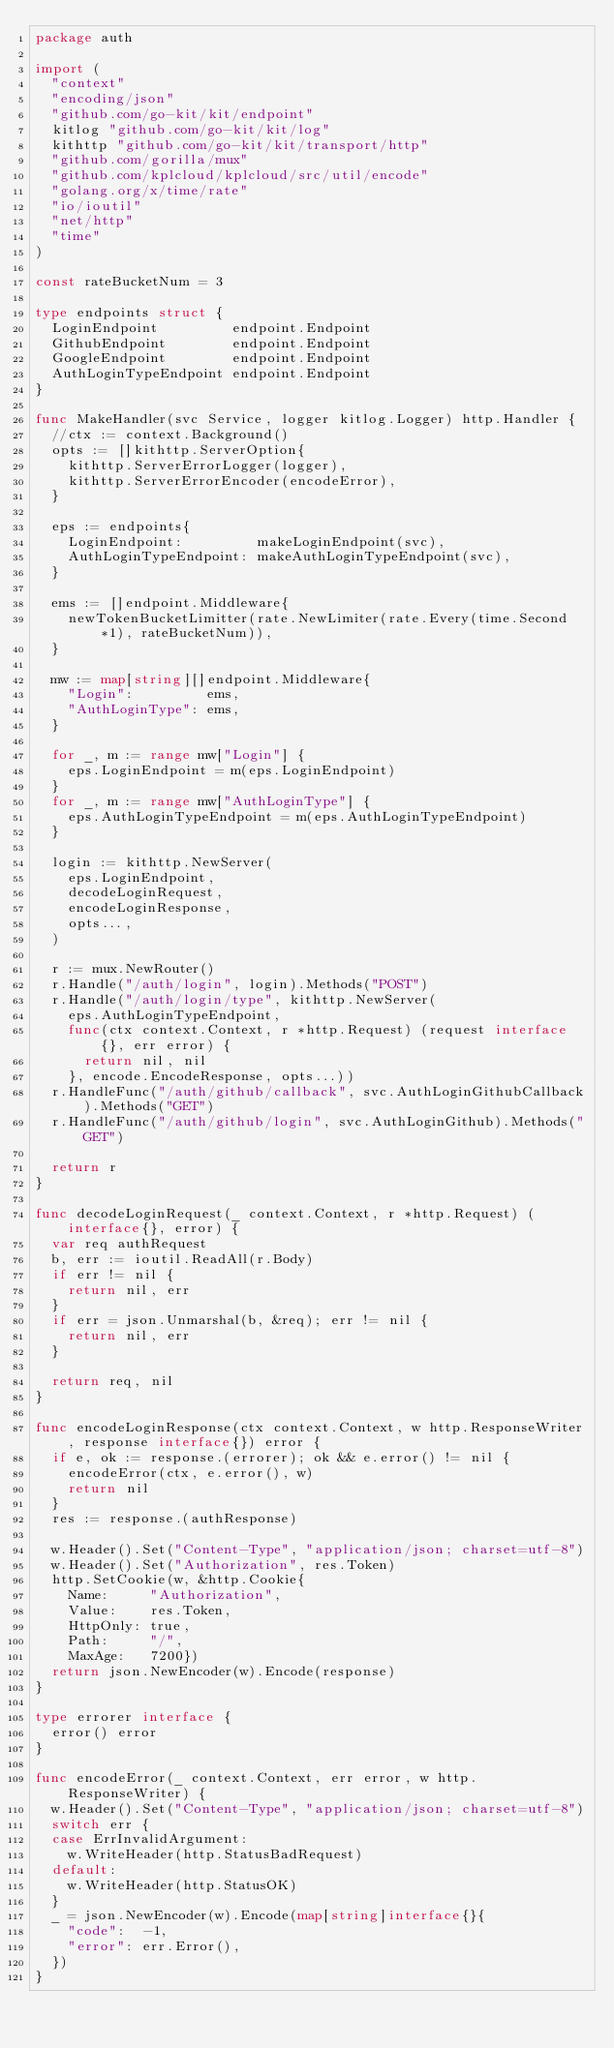Convert code to text. <code><loc_0><loc_0><loc_500><loc_500><_Go_>package auth

import (
	"context"
	"encoding/json"
	"github.com/go-kit/kit/endpoint"
	kitlog "github.com/go-kit/kit/log"
	kithttp "github.com/go-kit/kit/transport/http"
	"github.com/gorilla/mux"
	"github.com/kplcloud/kplcloud/src/util/encode"
	"golang.org/x/time/rate"
	"io/ioutil"
	"net/http"
	"time"
)

const rateBucketNum = 3

type endpoints struct {
	LoginEndpoint         endpoint.Endpoint
	GithubEndpoint        endpoint.Endpoint
	GoogleEndpoint        endpoint.Endpoint
	AuthLoginTypeEndpoint endpoint.Endpoint
}

func MakeHandler(svc Service, logger kitlog.Logger) http.Handler {
	//ctx := context.Background()
	opts := []kithttp.ServerOption{
		kithttp.ServerErrorLogger(logger),
		kithttp.ServerErrorEncoder(encodeError),
	}

	eps := endpoints{
		LoginEndpoint:         makeLoginEndpoint(svc),
		AuthLoginTypeEndpoint: makeAuthLoginTypeEndpoint(svc),
	}

	ems := []endpoint.Middleware{
		newTokenBucketLimitter(rate.NewLimiter(rate.Every(time.Second*1), rateBucketNum)),
	}

	mw := map[string][]endpoint.Middleware{
		"Login":         ems,
		"AuthLoginType": ems,
	}

	for _, m := range mw["Login"] {
		eps.LoginEndpoint = m(eps.LoginEndpoint)
	}
	for _, m := range mw["AuthLoginType"] {
		eps.AuthLoginTypeEndpoint = m(eps.AuthLoginTypeEndpoint)
	}

	login := kithttp.NewServer(
		eps.LoginEndpoint,
		decodeLoginRequest,
		encodeLoginResponse,
		opts...,
	)

	r := mux.NewRouter()
	r.Handle("/auth/login", login).Methods("POST")
	r.Handle("/auth/login/type", kithttp.NewServer(
		eps.AuthLoginTypeEndpoint,
		func(ctx context.Context, r *http.Request) (request interface{}, err error) {
			return nil, nil
		}, encode.EncodeResponse, opts...))
	r.HandleFunc("/auth/github/callback", svc.AuthLoginGithubCallback).Methods("GET")
	r.HandleFunc("/auth/github/login", svc.AuthLoginGithub).Methods("GET")

	return r
}

func decodeLoginRequest(_ context.Context, r *http.Request) (interface{}, error) {
	var req authRequest
	b, err := ioutil.ReadAll(r.Body)
	if err != nil {
		return nil, err
	}
	if err = json.Unmarshal(b, &req); err != nil {
		return nil, err
	}

	return req, nil
}

func encodeLoginResponse(ctx context.Context, w http.ResponseWriter, response interface{}) error {
	if e, ok := response.(errorer); ok && e.error() != nil {
		encodeError(ctx, e.error(), w)
		return nil
	}
	res := response.(authResponse)

	w.Header().Set("Content-Type", "application/json; charset=utf-8")
	w.Header().Set("Authorization", res.Token)
	http.SetCookie(w, &http.Cookie{
		Name:     "Authorization",
		Value:    res.Token,
		HttpOnly: true,
		Path:     "/",
		MaxAge:   7200})
	return json.NewEncoder(w).Encode(response)
}

type errorer interface {
	error() error
}

func encodeError(_ context.Context, err error, w http.ResponseWriter) {
	w.Header().Set("Content-Type", "application/json; charset=utf-8")
	switch err {
	case ErrInvalidArgument:
		w.WriteHeader(http.StatusBadRequest)
	default:
		w.WriteHeader(http.StatusOK)
	}
	_ = json.NewEncoder(w).Encode(map[string]interface{}{
		"code":  -1,
		"error": err.Error(),
	})
}
</code> 